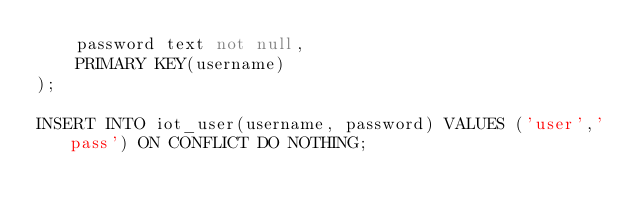Convert code to text. <code><loc_0><loc_0><loc_500><loc_500><_SQL_>    password text not null,
    PRIMARY KEY(username)
);

INSERT INTO iot_user(username, password) VALUES ('user','pass') ON CONFLICT DO NOTHING;</code> 